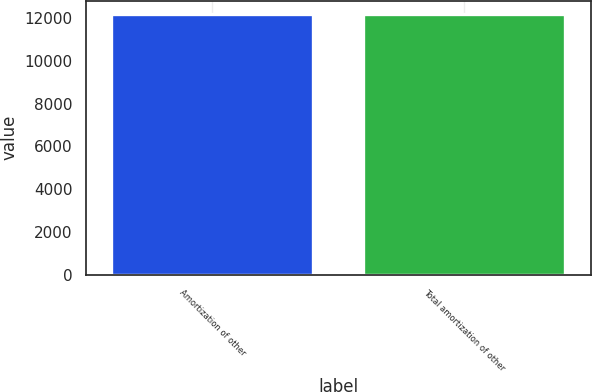<chart> <loc_0><loc_0><loc_500><loc_500><bar_chart><fcel>Amortization of other<fcel>Total amortization of other<nl><fcel>12199<fcel>12199.1<nl></chart> 